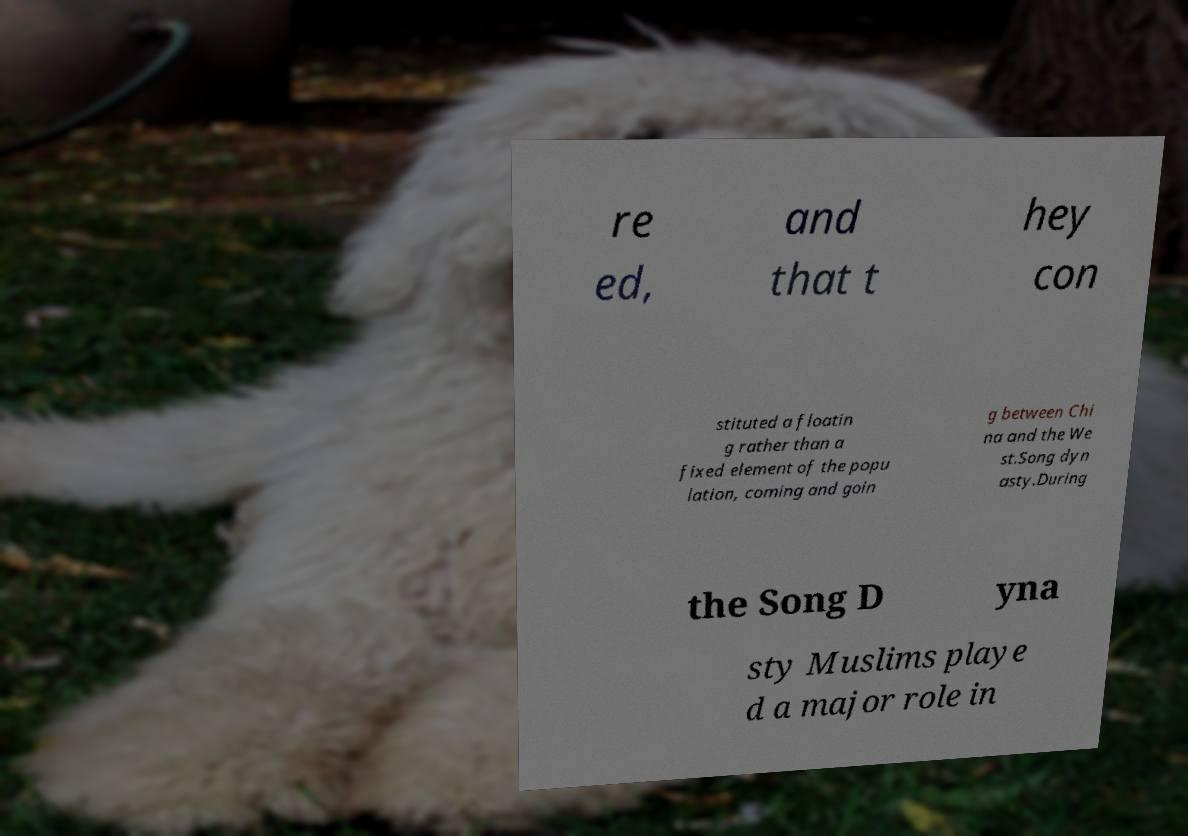Please read and relay the text visible in this image. What does it say? re ed, and that t hey con stituted a floatin g rather than a fixed element of the popu lation, coming and goin g between Chi na and the We st.Song dyn asty.During the Song D yna sty Muslims playe d a major role in 